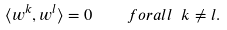Convert formula to latex. <formula><loc_0><loc_0><loc_500><loc_500>\langle w ^ { k } , w ^ { l } \rangle = 0 \quad f o r a l l \ k \neq l .</formula> 